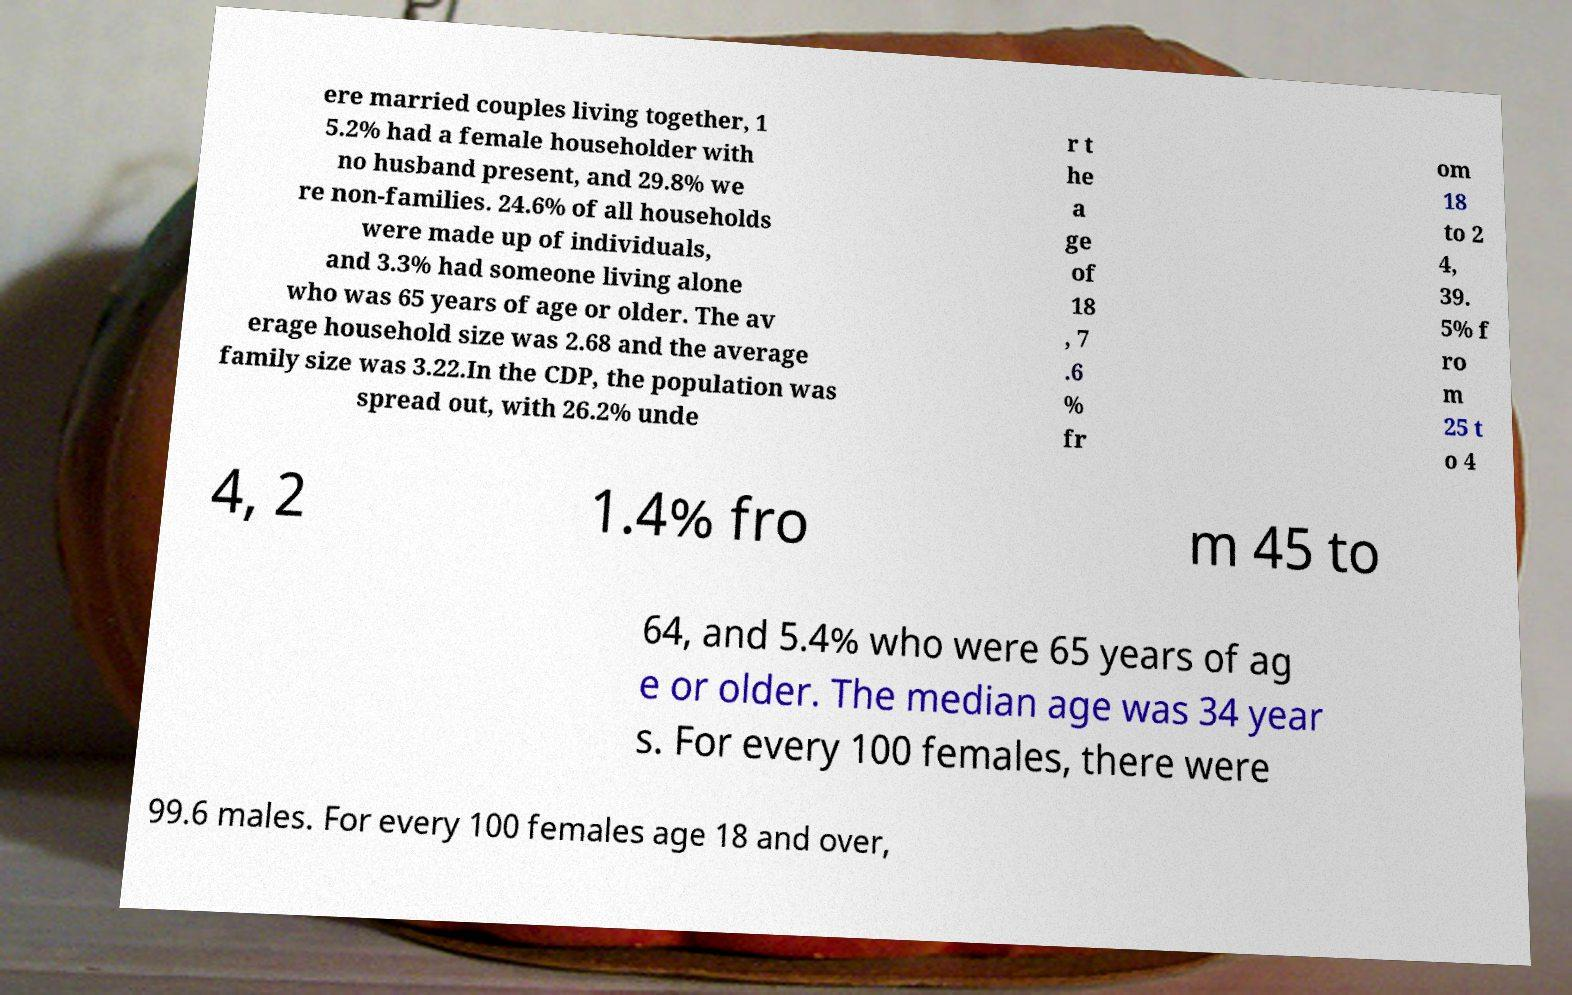Could you extract and type out the text from this image? ere married couples living together, 1 5.2% had a female householder with no husband present, and 29.8% we re non-families. 24.6% of all households were made up of individuals, and 3.3% had someone living alone who was 65 years of age or older. The av erage household size was 2.68 and the average family size was 3.22.In the CDP, the population was spread out, with 26.2% unde r t he a ge of 18 , 7 .6 % fr om 18 to 2 4, 39. 5% f ro m 25 t o 4 4, 2 1.4% fro m 45 to 64, and 5.4% who were 65 years of ag e or older. The median age was 34 year s. For every 100 females, there were 99.6 males. For every 100 females age 18 and over, 